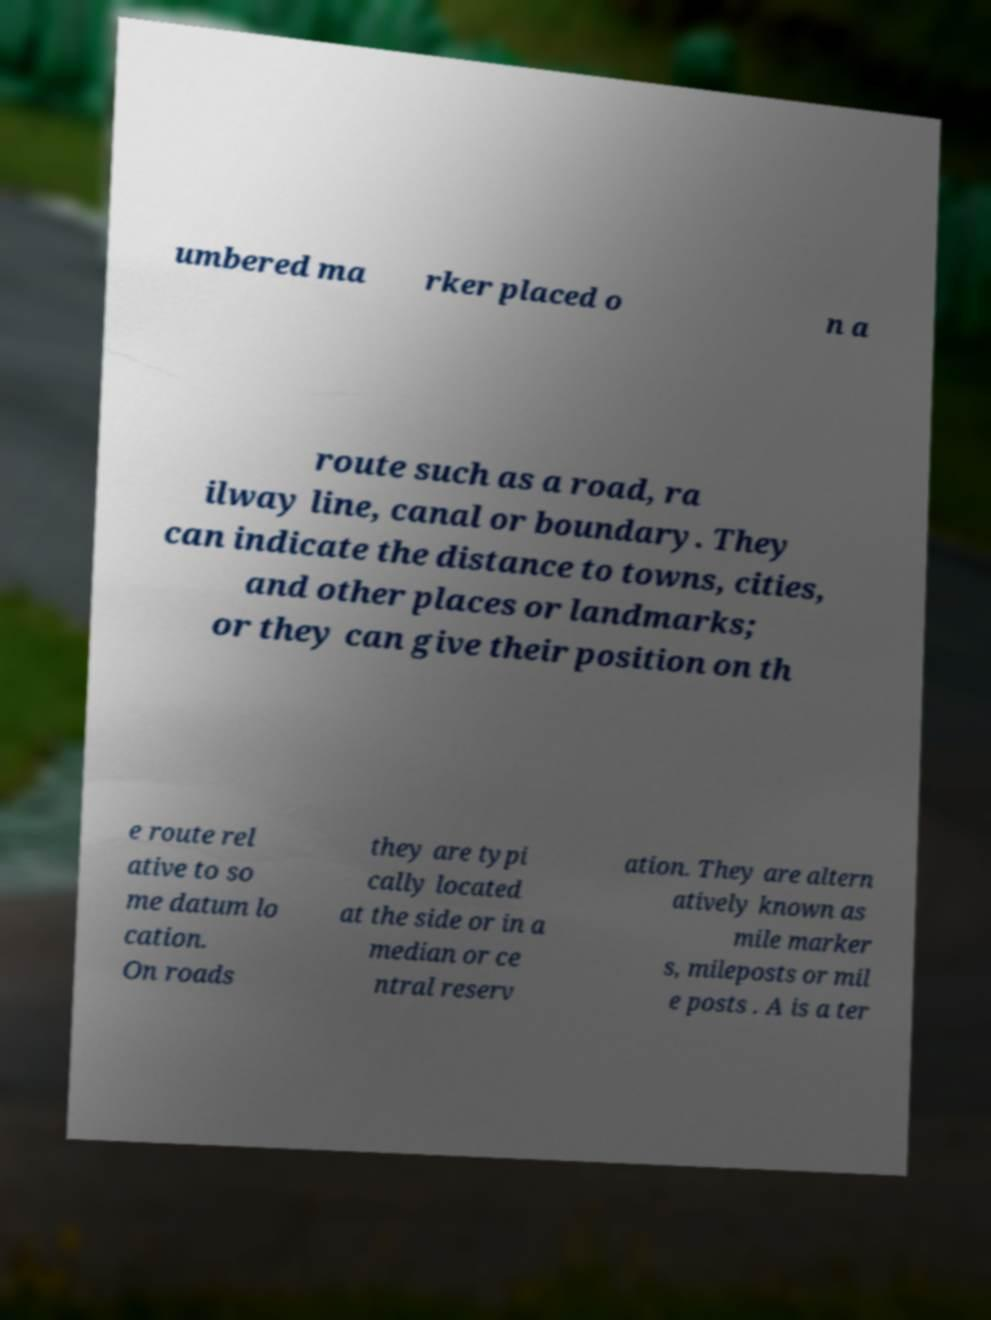Please identify and transcribe the text found in this image. umbered ma rker placed o n a route such as a road, ra ilway line, canal or boundary. They can indicate the distance to towns, cities, and other places or landmarks; or they can give their position on th e route rel ative to so me datum lo cation. On roads they are typi cally located at the side or in a median or ce ntral reserv ation. They are altern atively known as mile marker s, mileposts or mil e posts . A is a ter 